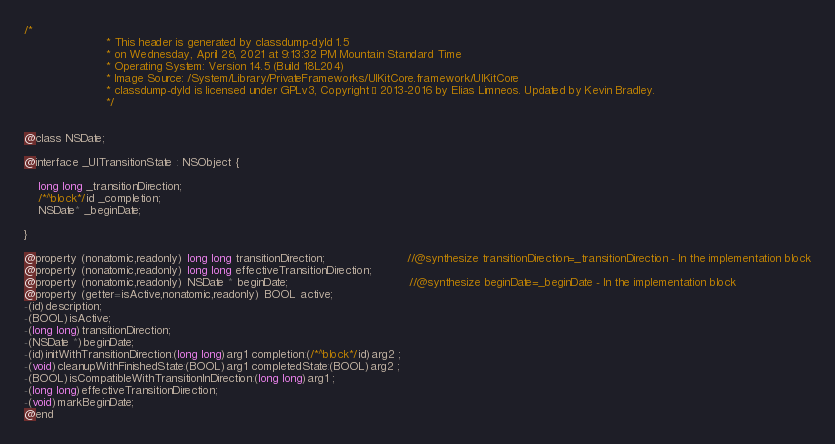Convert code to text. <code><loc_0><loc_0><loc_500><loc_500><_C_>/*
                       * This header is generated by classdump-dyld 1.5
                       * on Wednesday, April 28, 2021 at 9:13:32 PM Mountain Standard Time
                       * Operating System: Version 14.5 (Build 18L204)
                       * Image Source: /System/Library/PrivateFrameworks/UIKitCore.framework/UIKitCore
                       * classdump-dyld is licensed under GPLv3, Copyright © 2013-2016 by Elias Limneos. Updated by Kevin Bradley.
                       */


@class NSDate;

@interface _UITransitionState : NSObject {

	long long _transitionDirection;
	/*^block*/id _completion;
	NSDate* _beginDate;

}

@property (nonatomic,readonly) long long transitionDirection;                       //@synthesize transitionDirection=_transitionDirection - In the implementation block
@property (nonatomic,readonly) long long effectiveTransitionDirection; 
@property (nonatomic,readonly) NSDate * beginDate;                                  //@synthesize beginDate=_beginDate - In the implementation block
@property (getter=isActive,nonatomic,readonly) BOOL active; 
-(id)description;
-(BOOL)isActive;
-(long long)transitionDirection;
-(NSDate *)beginDate;
-(id)initWithTransitionDirection:(long long)arg1 completion:(/*^block*/id)arg2 ;
-(void)cleanupWithFinishedState:(BOOL)arg1 completedState:(BOOL)arg2 ;
-(BOOL)isCompatibleWithTransitionInDirection:(long long)arg1 ;
-(long long)effectiveTransitionDirection;
-(void)markBeginDate;
@end

</code> 